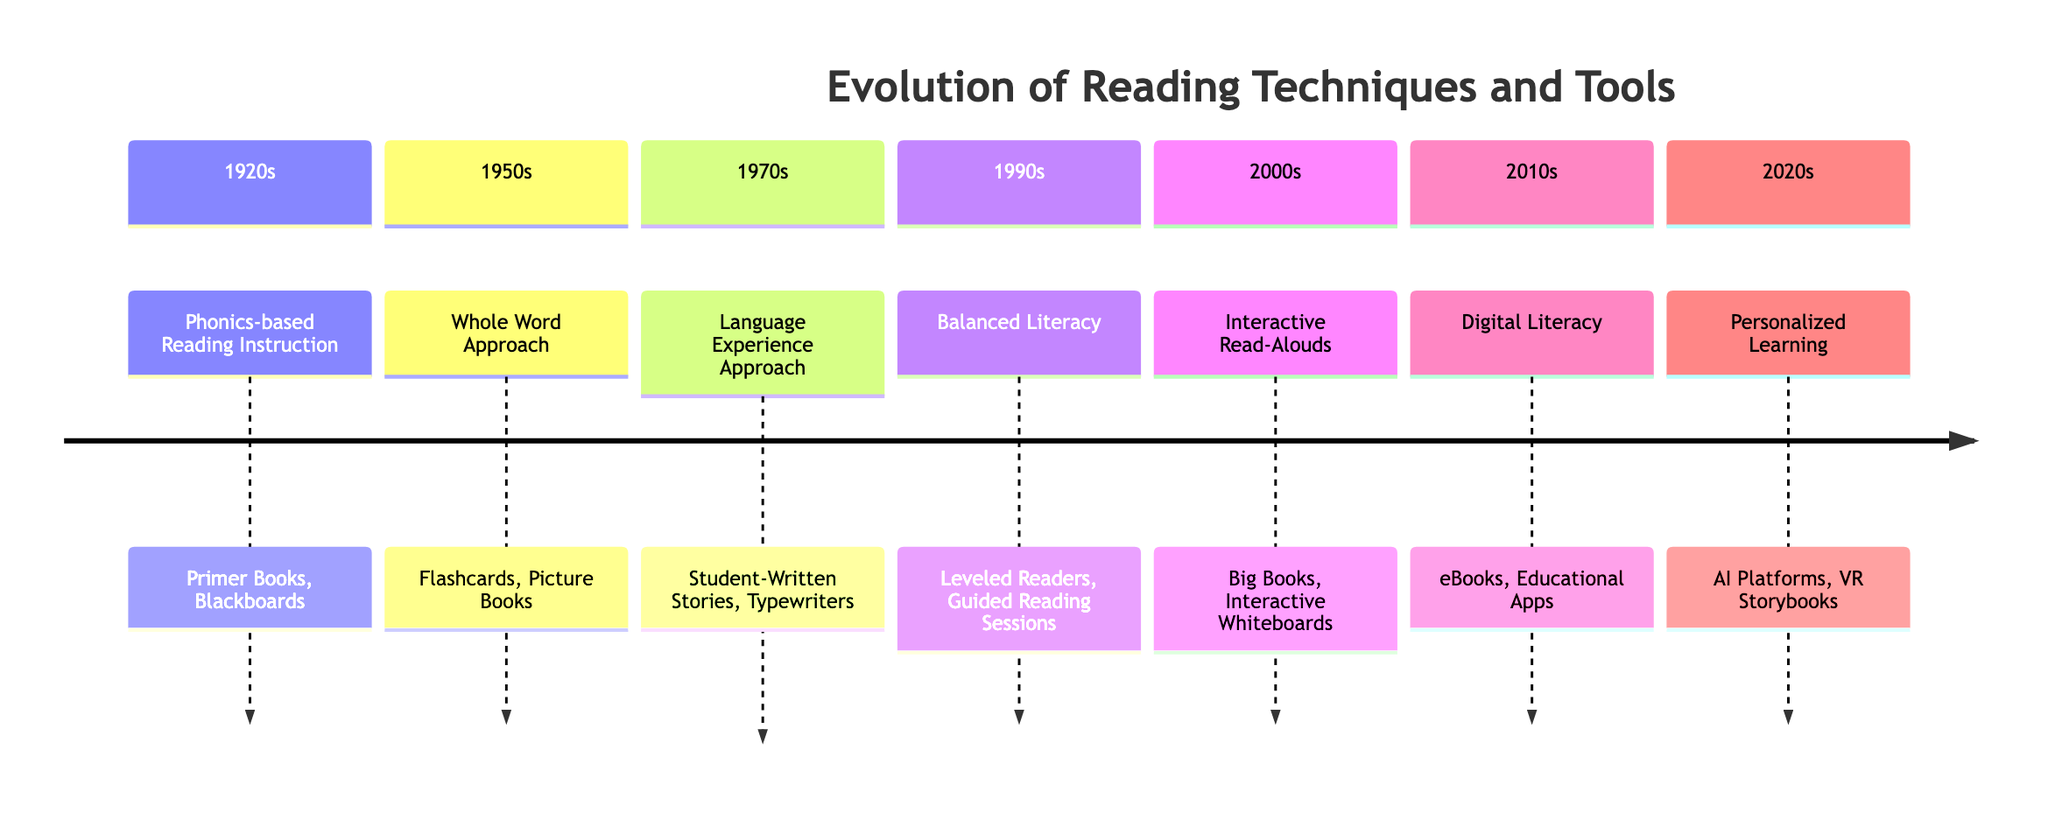What reading technique was used in 1920? The diagram indicates that in 1920, the reading technique used was "Phonics-based Reading Instruction." This information is directly stated in the timeline section for that year.
Answer: Phonics-based Reading Instruction What tools were associated with the Whole Word Approach in 1950? According to the timeline, the tools associated with the Whole Word Approach in 1950 were "Flashcards" and "Picture Books." These tools are listed under that specific technique in the diagram.
Answer: Flashcards, Picture Books How many techniques are listed in the timeline? By counting the distinct entries within the timeline, we identify that there are a total of 7 different reading techniques presented. This is done by referencing each section separately.
Answer: 7 What was a key characteristic of the Balanced Literacy approach introduced in 1990? The diagram describes Balanced Literacy as an integrated approach combining "phonics" with "whole language practices," which characterizes its method. The information is present in the description for that year.
Answer: Combined phonics and whole language Which reading technique introduced in 2010 emphasizes technology? The timeline shows that the reading technique introduced in 2010 is "Digital Literacy," which emphasizes the use of technology based tools. This is explicitly noted in the diagram.
Answer: Digital Literacy What are the tools used for Personalized Learning in 2020? The timeline states that the tools for Personalized Learning in 2020 include "Artificial Intelligence (AI) Platforms" and "Virtual Reality (VR) Storybooks." These tools are listed as essential for that technique in the diagram.
Answer: AI Platforms, VR Storybooks Which technique was introduced first according to the timeline? By examining the years listed, it is evident that "Phonics-based Reading Instruction," introduced in 1920, was the first technique detailed in the timeline. This is based on the chronological order of the years provided.
Answer: Phonics-based Reading Instruction What do the tools "Big Books" and "Interactive Whiteboards" belong to in the timeline? The diagram indicates that "Big Books" and "Interactive Whiteboards" are specific tools utilized within the "Interactive Read-Alouds" technique introduced in 2000. This information connects the tools directly to the technique.
Answer: Interactive Read-Alouds 